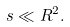<formula> <loc_0><loc_0><loc_500><loc_500>s \ll R ^ { 2 } .</formula> 